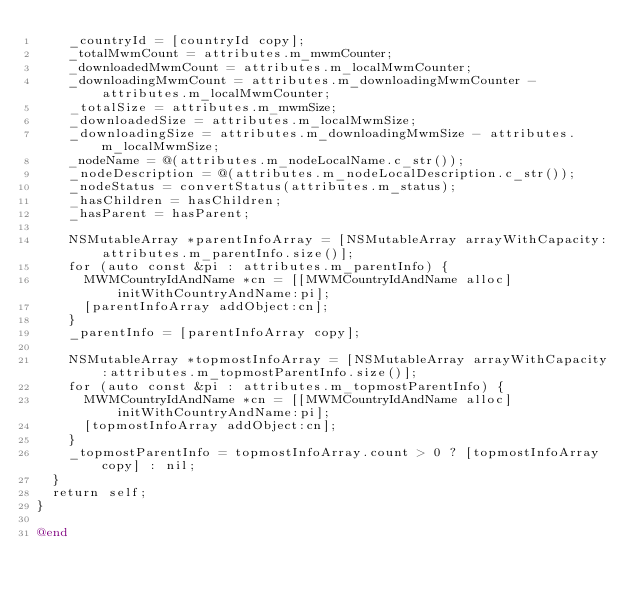<code> <loc_0><loc_0><loc_500><loc_500><_ObjectiveC_>    _countryId = [countryId copy];
    _totalMwmCount = attributes.m_mwmCounter;
    _downloadedMwmCount = attributes.m_localMwmCounter;
    _downloadingMwmCount = attributes.m_downloadingMwmCounter - attributes.m_localMwmCounter;
    _totalSize = attributes.m_mwmSize;
    _downloadedSize = attributes.m_localMwmSize;
    _downloadingSize = attributes.m_downloadingMwmSize - attributes.m_localMwmSize;
    _nodeName = @(attributes.m_nodeLocalName.c_str());
    _nodeDescription = @(attributes.m_nodeLocalDescription.c_str());
    _nodeStatus = convertStatus(attributes.m_status);
    _hasChildren = hasChildren;
    _hasParent = hasParent;

    NSMutableArray *parentInfoArray = [NSMutableArray arrayWithCapacity:attributes.m_parentInfo.size()];
    for (auto const &pi : attributes.m_parentInfo) {
      MWMCountryIdAndName *cn = [[MWMCountryIdAndName alloc] initWithCountryAndName:pi];
      [parentInfoArray addObject:cn];
    }
    _parentInfo = [parentInfoArray copy];

    NSMutableArray *topmostInfoArray = [NSMutableArray arrayWithCapacity:attributes.m_topmostParentInfo.size()];
    for (auto const &pi : attributes.m_topmostParentInfo) {
      MWMCountryIdAndName *cn = [[MWMCountryIdAndName alloc] initWithCountryAndName:pi];
      [topmostInfoArray addObject:cn];
    }
    _topmostParentInfo = topmostInfoArray.count > 0 ? [topmostInfoArray copy] : nil;
  }
  return self;
}

@end
</code> 